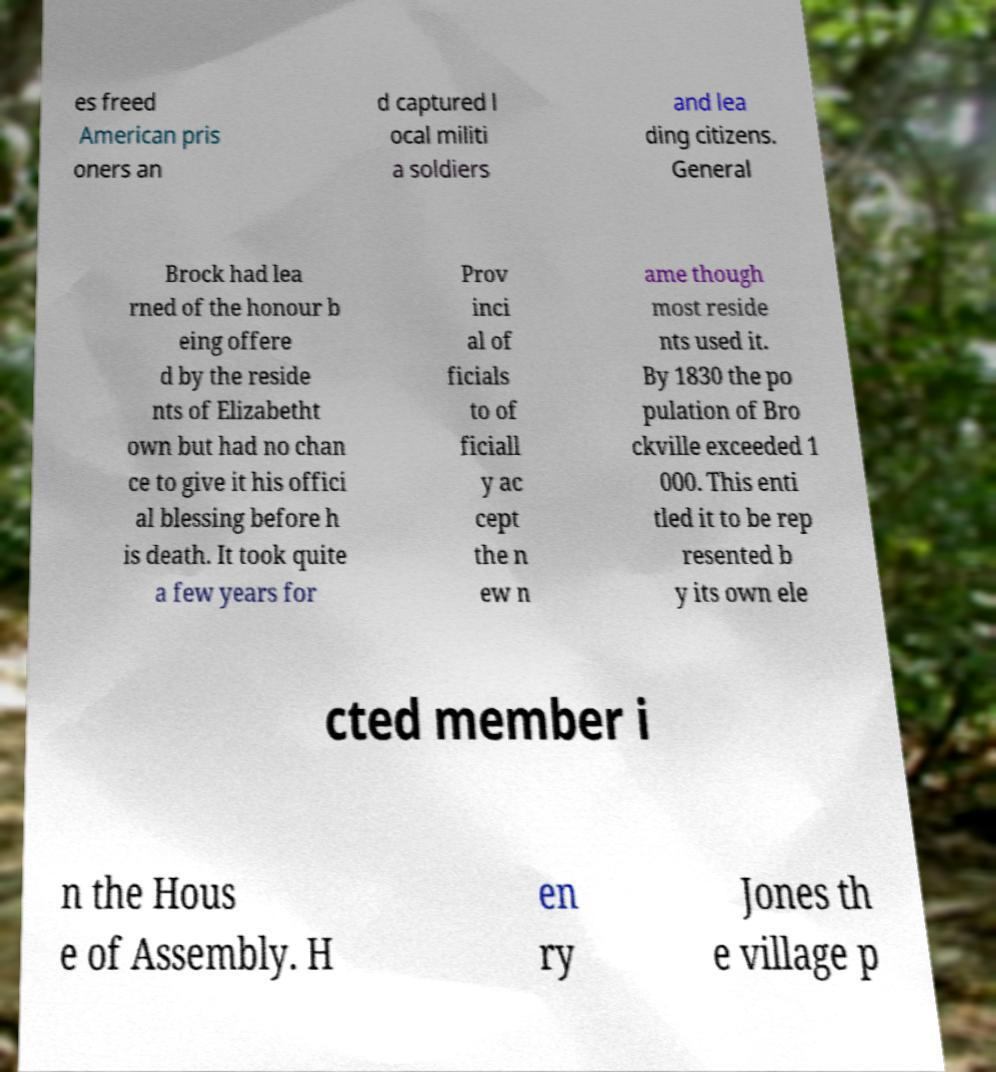I need the written content from this picture converted into text. Can you do that? es freed American pris oners an d captured l ocal militi a soldiers and lea ding citizens. General Brock had lea rned of the honour b eing offere d by the reside nts of Elizabetht own but had no chan ce to give it his offici al blessing before h is death. It took quite a few years for Prov inci al of ficials to of ficiall y ac cept the n ew n ame though most reside nts used it. By 1830 the po pulation of Bro ckville exceeded 1 000. This enti tled it to be rep resented b y its own ele cted member i n the Hous e of Assembly. H en ry Jones th e village p 